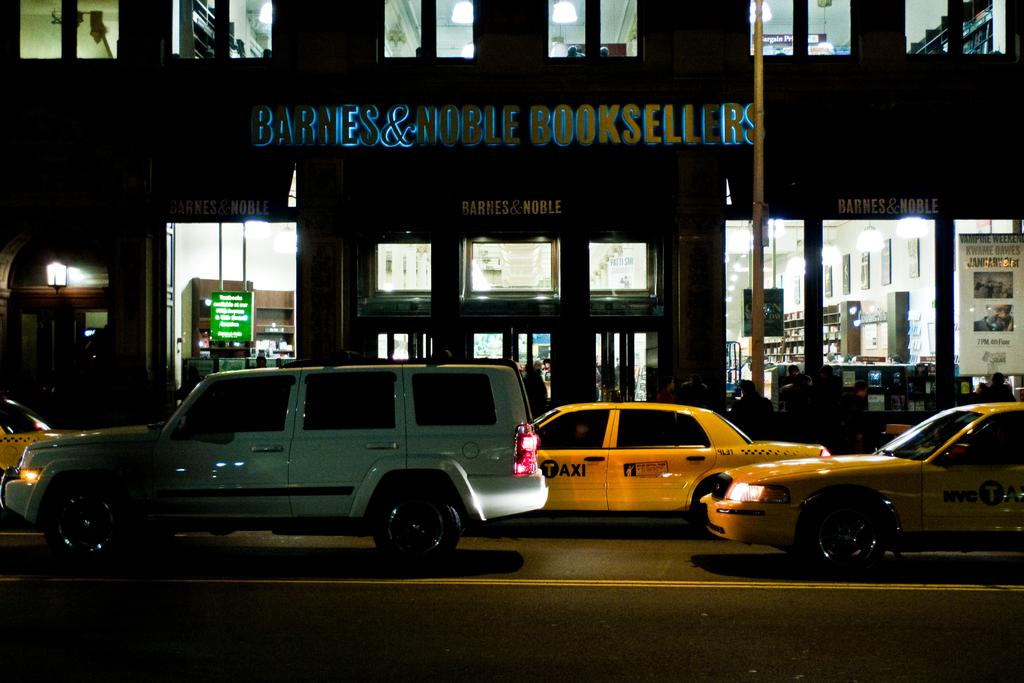<image>
Summarize the visual content of the image. Traffic on the city streets outside of a Barnes & Noble Booksellers store. 